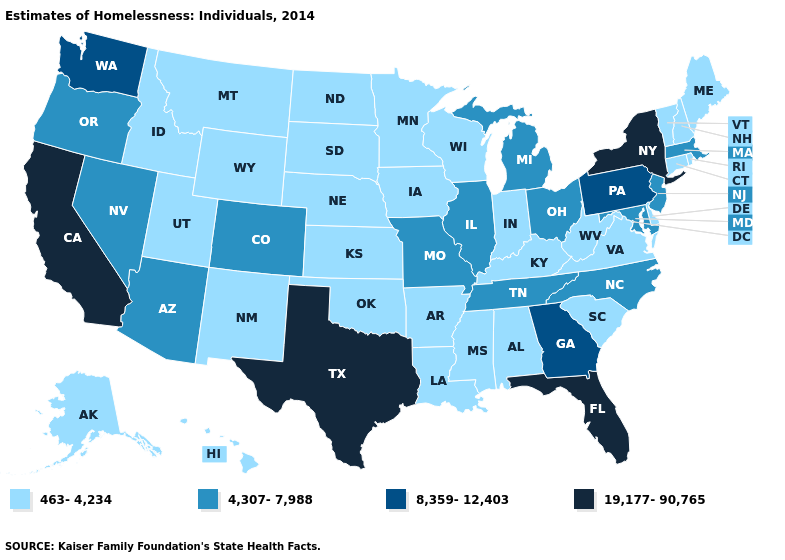What is the value of Indiana?
Be succinct. 463-4,234. What is the lowest value in the USA?
Give a very brief answer. 463-4,234. Name the states that have a value in the range 19,177-90,765?
Keep it brief. California, Florida, New York, Texas. What is the highest value in states that border Iowa?
Short answer required. 4,307-7,988. What is the lowest value in the South?
Be succinct. 463-4,234. Which states have the lowest value in the USA?
Give a very brief answer. Alabama, Alaska, Arkansas, Connecticut, Delaware, Hawaii, Idaho, Indiana, Iowa, Kansas, Kentucky, Louisiana, Maine, Minnesota, Mississippi, Montana, Nebraska, New Hampshire, New Mexico, North Dakota, Oklahoma, Rhode Island, South Carolina, South Dakota, Utah, Vermont, Virginia, West Virginia, Wisconsin, Wyoming. Does the first symbol in the legend represent the smallest category?
Be succinct. Yes. Does Colorado have the lowest value in the USA?
Concise answer only. No. Which states have the highest value in the USA?
Short answer required. California, Florida, New York, Texas. Does Tennessee have the lowest value in the USA?
Short answer required. No. What is the highest value in states that border New Hampshire?
Give a very brief answer. 4,307-7,988. Among the states that border Illinois , does Indiana have the lowest value?
Quick response, please. Yes. How many symbols are there in the legend?
Write a very short answer. 4. Does the first symbol in the legend represent the smallest category?
Give a very brief answer. Yes. Does Michigan have the highest value in the USA?
Write a very short answer. No. 